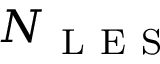<formula> <loc_0><loc_0><loc_500><loc_500>N _ { L E S }</formula> 